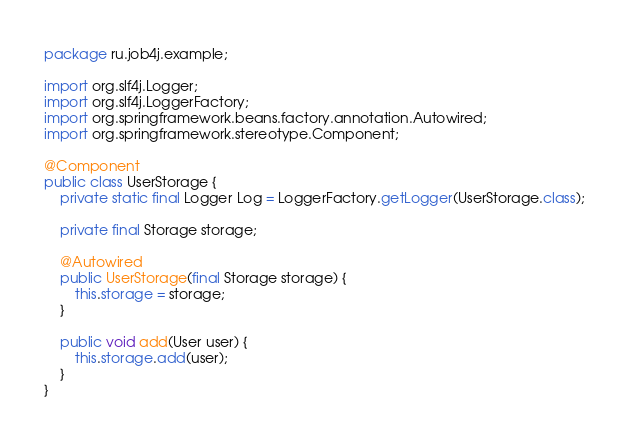Convert code to text. <code><loc_0><loc_0><loc_500><loc_500><_Java_>package ru.job4j.example;

import org.slf4j.Logger;
import org.slf4j.LoggerFactory;
import org.springframework.beans.factory.annotation.Autowired;
import org.springframework.stereotype.Component;

@Component
public class UserStorage {
    private static final Logger Log = LoggerFactory.getLogger(UserStorage.class);

    private final Storage storage;

    @Autowired
    public UserStorage(final Storage storage) {
        this.storage = storage;
    }

    public void add(User user) {
        this.storage.add(user);
    }
}
</code> 